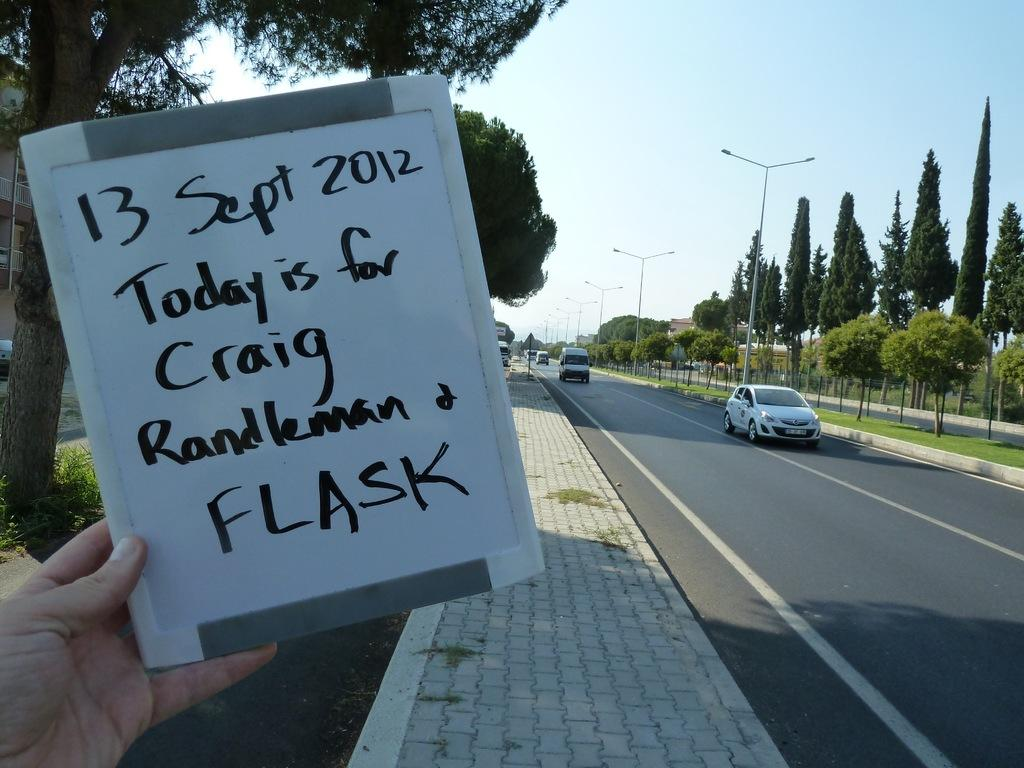What type of vertical structures can be seen in the image? There are light poles in the image. What other natural elements are present in the image? There are trees in the image. What is visible in the background of the image? The sky is visible in the image. What type of man-made structures can be seen in the image? There are vehicles on the road in the image. What is the person holding in the image? The person is holding a board in the image. What is written on the board? There is writing on the board. Where are the kittens playing in the image? There are no kittens present in the image. What type of structure is the person standing on in the image? There is no structure mentioned in the image, only light poles, trees, vehicles, and a person holding a board. 